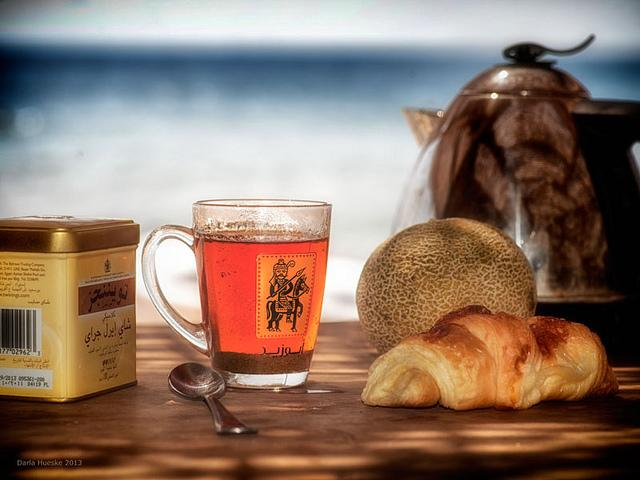What kind of beverage is there on the table top? Please explain your reasoning. tea. There is tea in the little cup next to the tin. 